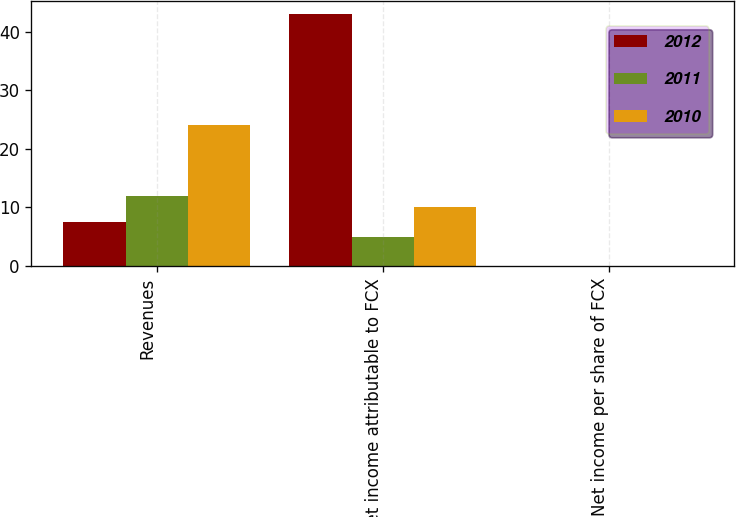Convert chart. <chart><loc_0><loc_0><loc_500><loc_500><stacked_bar_chart><ecel><fcel>Revenues<fcel>Net income attributable to FCX<fcel>Net income per share of FCX<nl><fcel>2012<fcel>7.5<fcel>43<fcel>0.05<nl><fcel>2011<fcel>12<fcel>5<fcel>0.01<nl><fcel>2010<fcel>24<fcel>10<fcel>0.01<nl></chart> 